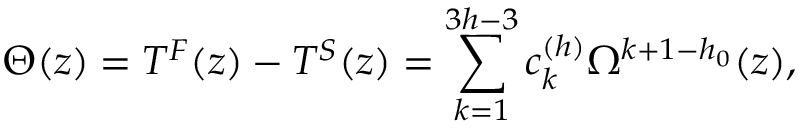Convert formula to latex. <formula><loc_0><loc_0><loc_500><loc_500>\Theta ( z ) = T ^ { F } ( z ) - T ^ { S } ( z ) = \sum _ { k = 1 } ^ { 3 h - 3 } c _ { k } ^ { ( h ) } \Omega ^ { k + 1 - h _ { 0 } } ( z ) ,</formula> 